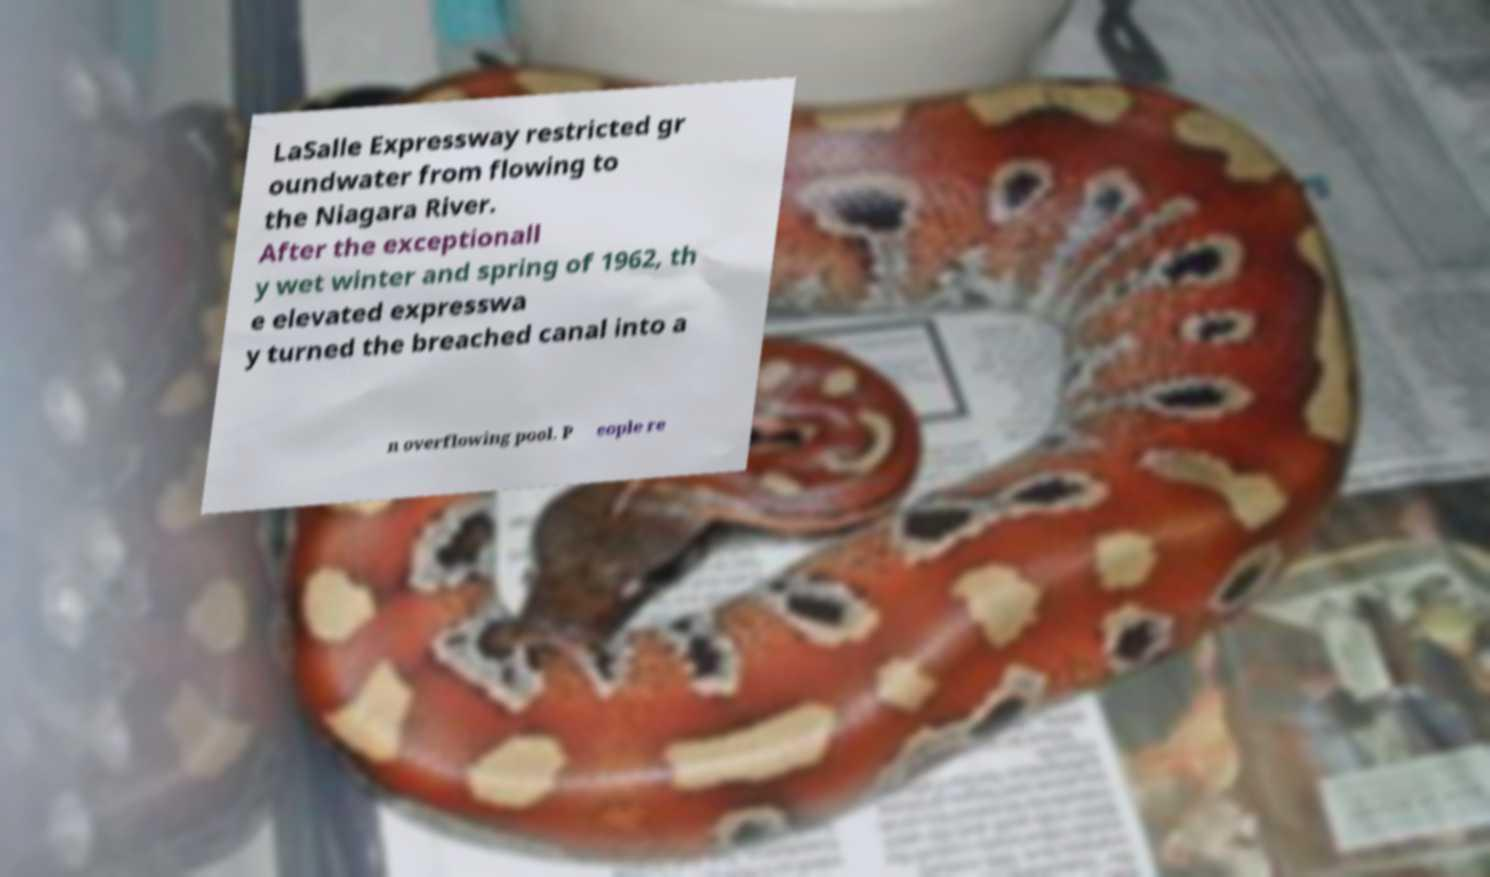What messages or text are displayed in this image? I need them in a readable, typed format. LaSalle Expressway restricted gr oundwater from flowing to the Niagara River. After the exceptionall y wet winter and spring of 1962, th e elevated expresswa y turned the breached canal into a n overflowing pool. P eople re 